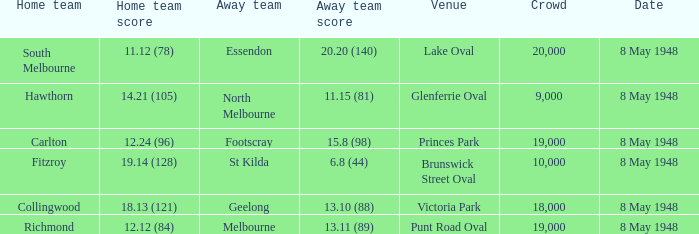Which away team has a home score of 14.21 (105)? North Melbourne. 